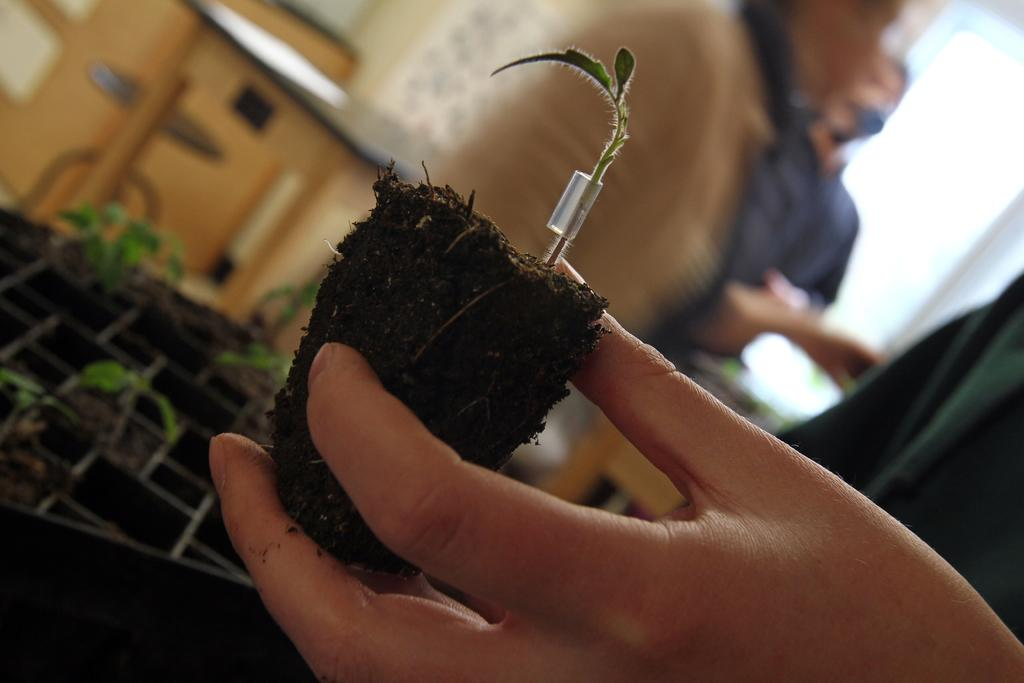Who is present in the image? There is a man in the image. What is the man holding in his hand? The man is holding a plant in his hand. Can you describe the background of the image? The background of the image is blurred. What type of ball is the man playing with in the image? There is no ball present in the image; the man is holding a plant. 